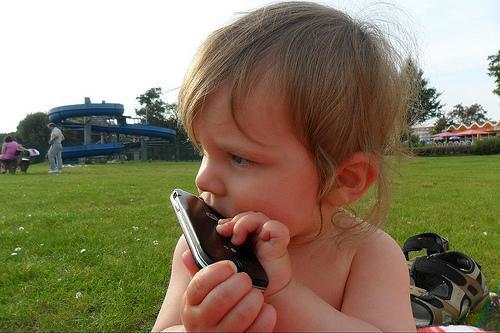How many people are in this picture?
Give a very brief answer. 3. 